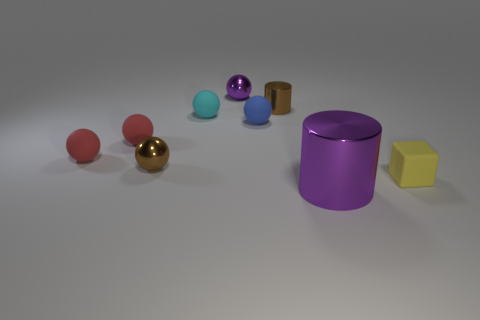Subtract all small red matte spheres. How many spheres are left? 4 Subtract all red balls. How many balls are left? 4 Subtract 1 spheres. How many spheres are left? 5 Subtract all purple balls. Subtract all yellow blocks. How many balls are left? 5 Subtract all cylinders. How many objects are left? 7 Subtract all small cyan rubber spheres. Subtract all small red balls. How many objects are left? 6 Add 6 brown metallic spheres. How many brown metallic spheres are left? 7 Add 4 small purple matte blocks. How many small purple matte blocks exist? 4 Subtract 0 green cylinders. How many objects are left? 9 